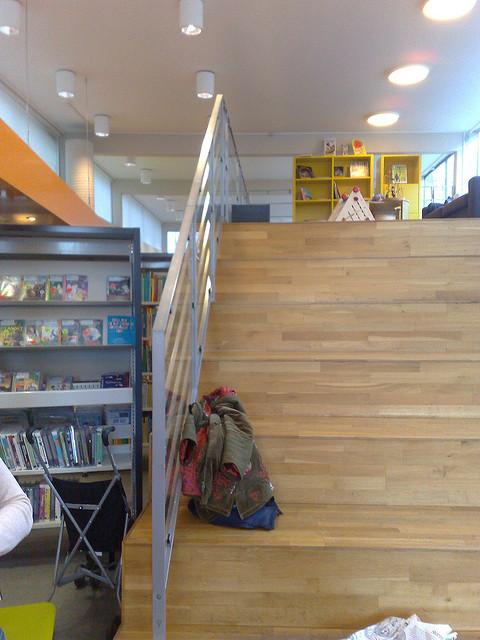Is this a library?
Give a very brief answer. Yes. Whose jackets are being left on the staircase?
Short answer required. Children's. How many bookshelves?
Write a very short answer. 3. 